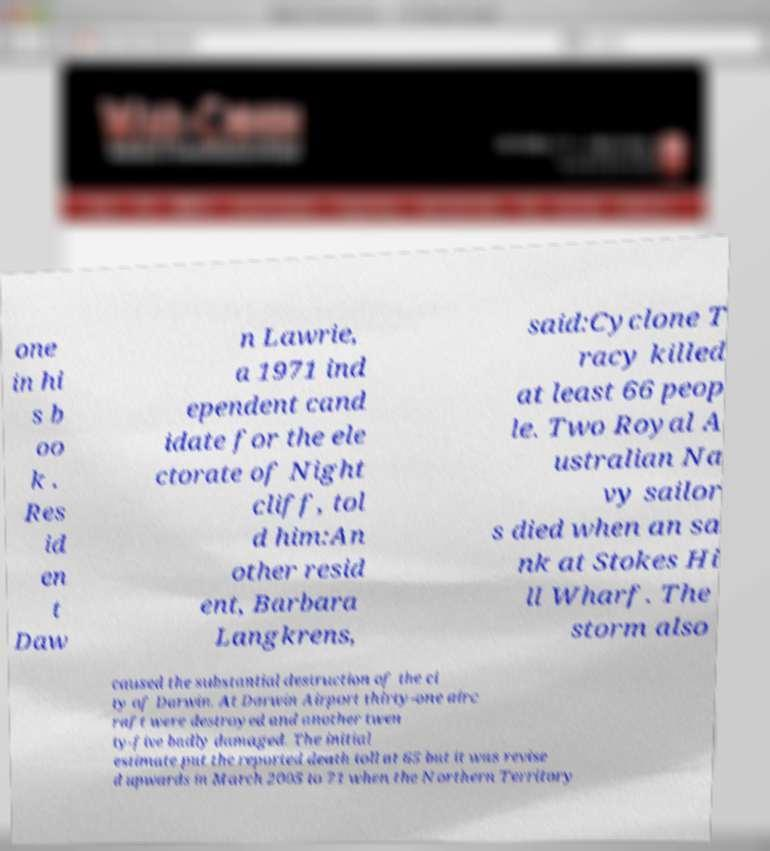There's text embedded in this image that I need extracted. Can you transcribe it verbatim? one in hi s b oo k . Res id en t Daw n Lawrie, a 1971 ind ependent cand idate for the ele ctorate of Night cliff, tol d him:An other resid ent, Barbara Langkrens, said:Cyclone T racy killed at least 66 peop le. Two Royal A ustralian Na vy sailor s died when an sa nk at Stokes Hi ll Wharf. The storm also caused the substantial destruction of the ci ty of Darwin. At Darwin Airport thirty-one airc raft were destroyed and another twen ty-five badly damaged. The initial estimate put the reported death toll at 65 but it was revise d upwards in March 2005 to 71 when the Northern Territory 